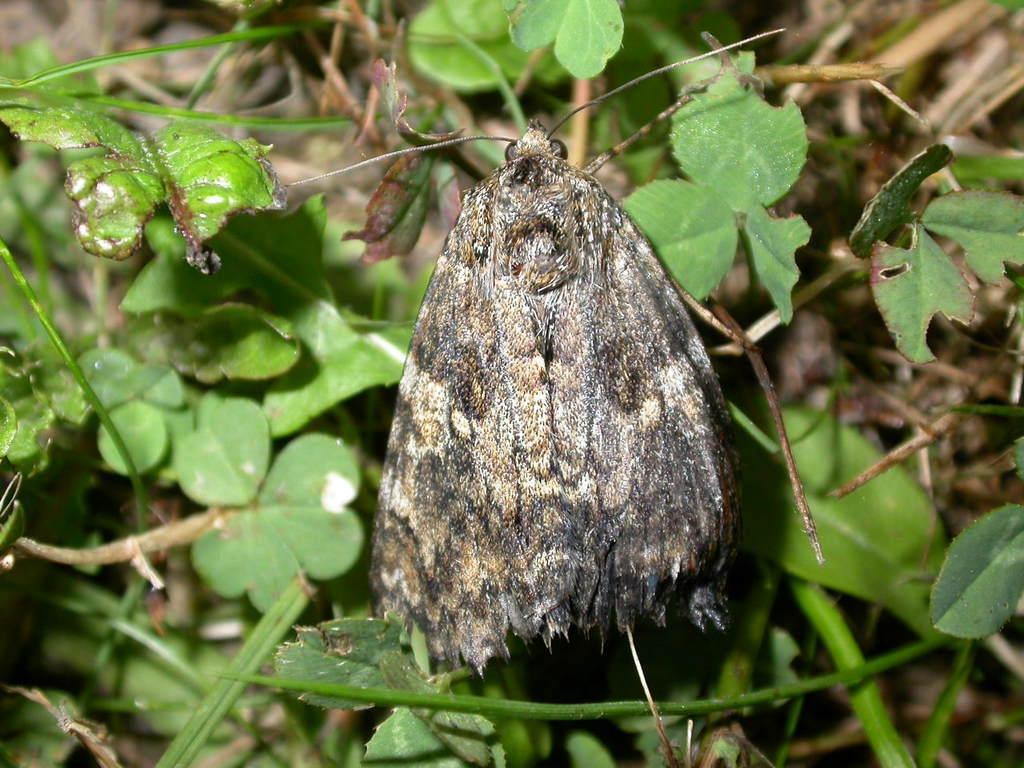Describe this image in one or two sentences. In the image there is a moth standing on the land with grass on it. 